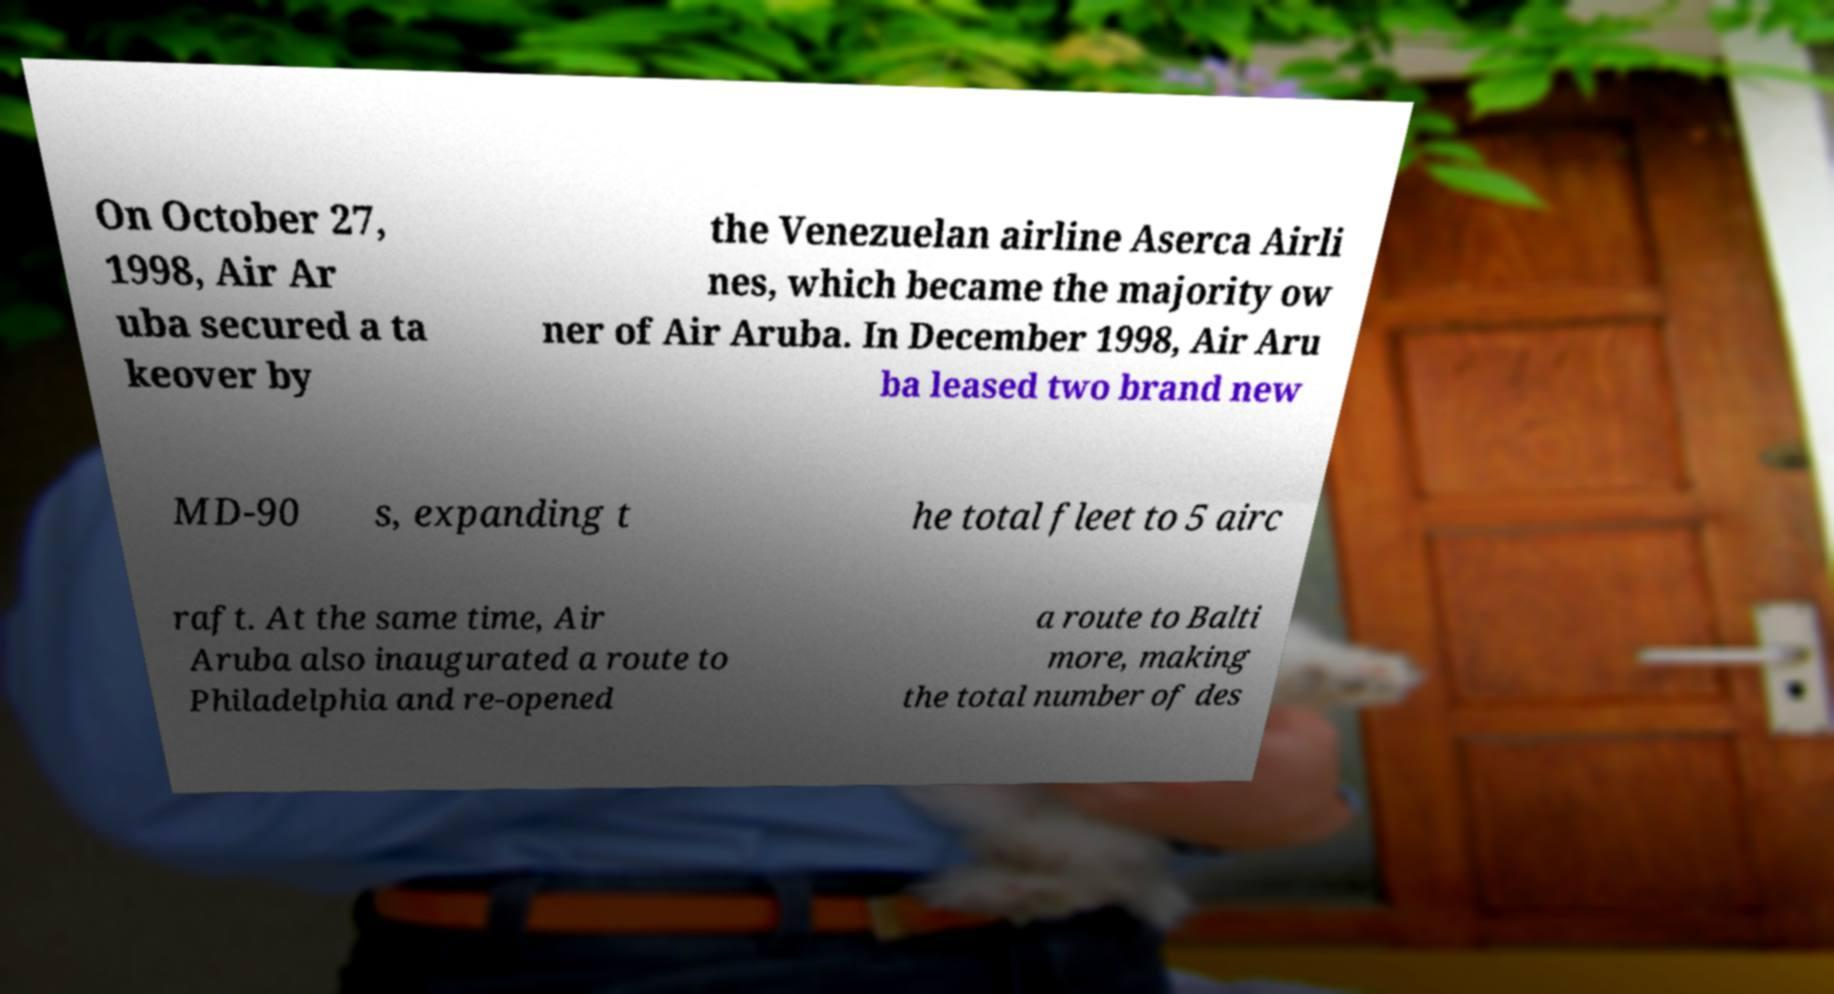Could you extract and type out the text from this image? On October 27, 1998, Air Ar uba secured a ta keover by the Venezuelan airline Aserca Airli nes, which became the majority ow ner of Air Aruba. In December 1998, Air Aru ba leased two brand new MD-90 s, expanding t he total fleet to 5 airc raft. At the same time, Air Aruba also inaugurated a route to Philadelphia and re-opened a route to Balti more, making the total number of des 